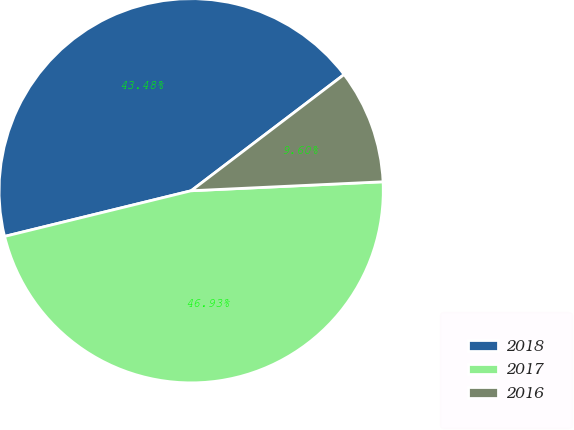<chart> <loc_0><loc_0><loc_500><loc_500><pie_chart><fcel>2018<fcel>2017<fcel>2016<nl><fcel>43.48%<fcel>46.93%<fcel>9.6%<nl></chart> 